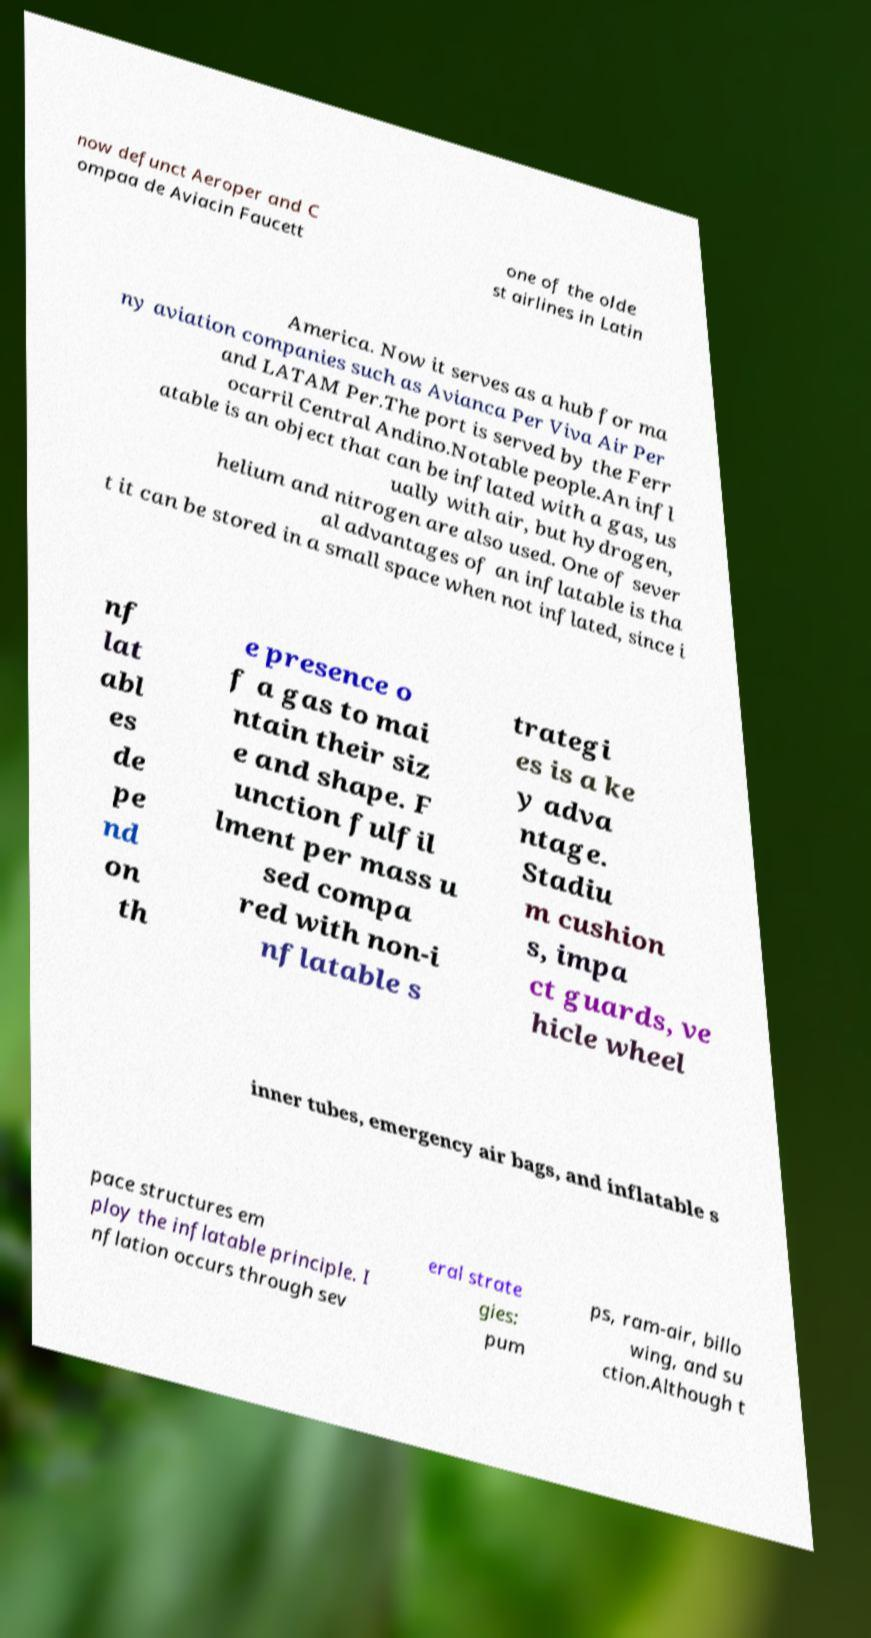For documentation purposes, I need the text within this image transcribed. Could you provide that? now defunct Aeroper and C ompaa de Aviacin Faucett one of the olde st airlines in Latin America. Now it serves as a hub for ma ny aviation companies such as Avianca Per Viva Air Per and LATAM Per.The port is served by the Ferr ocarril Central Andino.Notable people.An infl atable is an object that can be inflated with a gas, us ually with air, but hydrogen, helium and nitrogen are also used. One of sever al advantages of an inflatable is tha t it can be stored in a small space when not inflated, since i nf lat abl es de pe nd on th e presence o f a gas to mai ntain their siz e and shape. F unction fulfil lment per mass u sed compa red with non-i nflatable s trategi es is a ke y adva ntage. Stadiu m cushion s, impa ct guards, ve hicle wheel inner tubes, emergency air bags, and inflatable s pace structures em ploy the inflatable principle. I nflation occurs through sev eral strate gies: pum ps, ram-air, billo wing, and su ction.Although t 